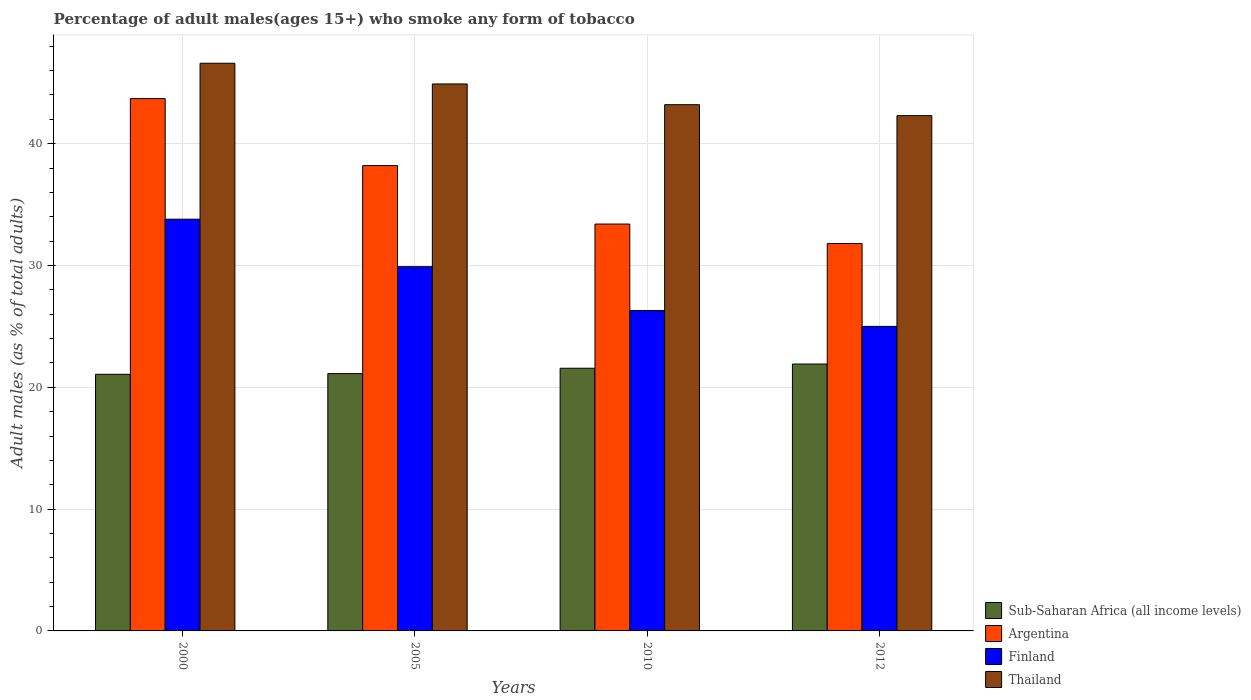How many different coloured bars are there?
Ensure brevity in your answer.  4. Are the number of bars per tick equal to the number of legend labels?
Your answer should be very brief. Yes. Are the number of bars on each tick of the X-axis equal?
Your response must be concise. Yes. How many bars are there on the 1st tick from the left?
Provide a short and direct response. 4. How many bars are there on the 4th tick from the right?
Provide a succinct answer. 4. What is the label of the 4th group of bars from the left?
Ensure brevity in your answer.  2012. In how many cases, is the number of bars for a given year not equal to the number of legend labels?
Provide a succinct answer. 0. What is the percentage of adult males who smoke in Finland in 2000?
Ensure brevity in your answer.  33.8. Across all years, what is the maximum percentage of adult males who smoke in Finland?
Offer a very short reply. 33.8. Across all years, what is the minimum percentage of adult males who smoke in Thailand?
Provide a short and direct response. 42.3. In which year was the percentage of adult males who smoke in Thailand maximum?
Your response must be concise. 2000. What is the total percentage of adult males who smoke in Sub-Saharan Africa (all income levels) in the graph?
Offer a very short reply. 85.66. What is the difference between the percentage of adult males who smoke in Thailand in 2000 and that in 2005?
Provide a short and direct response. 1.7. What is the difference between the percentage of adult males who smoke in Thailand in 2005 and the percentage of adult males who smoke in Sub-Saharan Africa (all income levels) in 2012?
Offer a very short reply. 22.99. What is the average percentage of adult males who smoke in Finland per year?
Give a very brief answer. 28.75. In the year 2012, what is the difference between the percentage of adult males who smoke in Finland and percentage of adult males who smoke in Thailand?
Your response must be concise. -17.3. In how many years, is the percentage of adult males who smoke in Thailand greater than 8 %?
Offer a very short reply. 4. What is the ratio of the percentage of adult males who smoke in Finland in 2000 to that in 2005?
Keep it short and to the point. 1.13. Is the percentage of adult males who smoke in Argentina in 2010 less than that in 2012?
Provide a short and direct response. No. What is the difference between the highest and the second highest percentage of adult males who smoke in Sub-Saharan Africa (all income levels)?
Your answer should be very brief. 0.35. What is the difference between the highest and the lowest percentage of adult males who smoke in Thailand?
Provide a short and direct response. 4.3. What does the 1st bar from the right in 2010 represents?
Offer a terse response. Thailand. How many bars are there?
Ensure brevity in your answer.  16. Are all the bars in the graph horizontal?
Offer a terse response. No. What is the difference between two consecutive major ticks on the Y-axis?
Provide a succinct answer. 10. How are the legend labels stacked?
Your response must be concise. Vertical. What is the title of the graph?
Provide a short and direct response. Percentage of adult males(ages 15+) who smoke any form of tobacco. Does "Heavily indebted poor countries" appear as one of the legend labels in the graph?
Provide a succinct answer. No. What is the label or title of the Y-axis?
Keep it short and to the point. Adult males (as % of total adults). What is the Adult males (as % of total adults) of Sub-Saharan Africa (all income levels) in 2000?
Keep it short and to the point. 21.07. What is the Adult males (as % of total adults) of Argentina in 2000?
Your answer should be compact. 43.7. What is the Adult males (as % of total adults) in Finland in 2000?
Ensure brevity in your answer.  33.8. What is the Adult males (as % of total adults) of Thailand in 2000?
Your answer should be very brief. 46.6. What is the Adult males (as % of total adults) in Sub-Saharan Africa (all income levels) in 2005?
Give a very brief answer. 21.12. What is the Adult males (as % of total adults) of Argentina in 2005?
Give a very brief answer. 38.2. What is the Adult males (as % of total adults) in Finland in 2005?
Give a very brief answer. 29.9. What is the Adult males (as % of total adults) in Thailand in 2005?
Offer a very short reply. 44.9. What is the Adult males (as % of total adults) in Sub-Saharan Africa (all income levels) in 2010?
Your answer should be very brief. 21.56. What is the Adult males (as % of total adults) of Argentina in 2010?
Offer a very short reply. 33.4. What is the Adult males (as % of total adults) in Finland in 2010?
Provide a succinct answer. 26.3. What is the Adult males (as % of total adults) in Thailand in 2010?
Provide a succinct answer. 43.2. What is the Adult males (as % of total adults) of Sub-Saharan Africa (all income levels) in 2012?
Keep it short and to the point. 21.91. What is the Adult males (as % of total adults) of Argentina in 2012?
Make the answer very short. 31.8. What is the Adult males (as % of total adults) of Thailand in 2012?
Ensure brevity in your answer.  42.3. Across all years, what is the maximum Adult males (as % of total adults) in Sub-Saharan Africa (all income levels)?
Provide a short and direct response. 21.91. Across all years, what is the maximum Adult males (as % of total adults) of Argentina?
Ensure brevity in your answer.  43.7. Across all years, what is the maximum Adult males (as % of total adults) of Finland?
Your answer should be compact. 33.8. Across all years, what is the maximum Adult males (as % of total adults) in Thailand?
Offer a very short reply. 46.6. Across all years, what is the minimum Adult males (as % of total adults) in Sub-Saharan Africa (all income levels)?
Offer a very short reply. 21.07. Across all years, what is the minimum Adult males (as % of total adults) of Argentina?
Keep it short and to the point. 31.8. Across all years, what is the minimum Adult males (as % of total adults) of Finland?
Offer a very short reply. 25. Across all years, what is the minimum Adult males (as % of total adults) in Thailand?
Keep it short and to the point. 42.3. What is the total Adult males (as % of total adults) of Sub-Saharan Africa (all income levels) in the graph?
Provide a short and direct response. 85.66. What is the total Adult males (as % of total adults) of Argentina in the graph?
Your response must be concise. 147.1. What is the total Adult males (as % of total adults) in Finland in the graph?
Give a very brief answer. 115. What is the total Adult males (as % of total adults) in Thailand in the graph?
Your response must be concise. 177. What is the difference between the Adult males (as % of total adults) in Sub-Saharan Africa (all income levels) in 2000 and that in 2005?
Make the answer very short. -0.06. What is the difference between the Adult males (as % of total adults) in Finland in 2000 and that in 2005?
Offer a terse response. 3.9. What is the difference between the Adult males (as % of total adults) of Sub-Saharan Africa (all income levels) in 2000 and that in 2010?
Give a very brief answer. -0.5. What is the difference between the Adult males (as % of total adults) in Finland in 2000 and that in 2010?
Offer a very short reply. 7.5. What is the difference between the Adult males (as % of total adults) of Thailand in 2000 and that in 2010?
Provide a short and direct response. 3.4. What is the difference between the Adult males (as % of total adults) of Sub-Saharan Africa (all income levels) in 2000 and that in 2012?
Give a very brief answer. -0.84. What is the difference between the Adult males (as % of total adults) in Sub-Saharan Africa (all income levels) in 2005 and that in 2010?
Offer a terse response. -0.44. What is the difference between the Adult males (as % of total adults) in Finland in 2005 and that in 2010?
Your answer should be compact. 3.6. What is the difference between the Adult males (as % of total adults) in Sub-Saharan Africa (all income levels) in 2005 and that in 2012?
Give a very brief answer. -0.79. What is the difference between the Adult males (as % of total adults) in Argentina in 2005 and that in 2012?
Ensure brevity in your answer.  6.4. What is the difference between the Adult males (as % of total adults) of Finland in 2005 and that in 2012?
Provide a short and direct response. 4.9. What is the difference between the Adult males (as % of total adults) in Thailand in 2005 and that in 2012?
Give a very brief answer. 2.6. What is the difference between the Adult males (as % of total adults) of Sub-Saharan Africa (all income levels) in 2010 and that in 2012?
Ensure brevity in your answer.  -0.35. What is the difference between the Adult males (as % of total adults) in Finland in 2010 and that in 2012?
Offer a terse response. 1.3. What is the difference between the Adult males (as % of total adults) of Thailand in 2010 and that in 2012?
Give a very brief answer. 0.9. What is the difference between the Adult males (as % of total adults) of Sub-Saharan Africa (all income levels) in 2000 and the Adult males (as % of total adults) of Argentina in 2005?
Provide a short and direct response. -17.13. What is the difference between the Adult males (as % of total adults) of Sub-Saharan Africa (all income levels) in 2000 and the Adult males (as % of total adults) of Finland in 2005?
Give a very brief answer. -8.83. What is the difference between the Adult males (as % of total adults) in Sub-Saharan Africa (all income levels) in 2000 and the Adult males (as % of total adults) in Thailand in 2005?
Offer a very short reply. -23.83. What is the difference between the Adult males (as % of total adults) in Argentina in 2000 and the Adult males (as % of total adults) in Finland in 2005?
Provide a short and direct response. 13.8. What is the difference between the Adult males (as % of total adults) of Argentina in 2000 and the Adult males (as % of total adults) of Thailand in 2005?
Ensure brevity in your answer.  -1.2. What is the difference between the Adult males (as % of total adults) of Sub-Saharan Africa (all income levels) in 2000 and the Adult males (as % of total adults) of Argentina in 2010?
Give a very brief answer. -12.33. What is the difference between the Adult males (as % of total adults) in Sub-Saharan Africa (all income levels) in 2000 and the Adult males (as % of total adults) in Finland in 2010?
Provide a succinct answer. -5.23. What is the difference between the Adult males (as % of total adults) in Sub-Saharan Africa (all income levels) in 2000 and the Adult males (as % of total adults) in Thailand in 2010?
Your answer should be very brief. -22.13. What is the difference between the Adult males (as % of total adults) in Argentina in 2000 and the Adult males (as % of total adults) in Finland in 2010?
Keep it short and to the point. 17.4. What is the difference between the Adult males (as % of total adults) in Argentina in 2000 and the Adult males (as % of total adults) in Thailand in 2010?
Your answer should be very brief. 0.5. What is the difference between the Adult males (as % of total adults) of Sub-Saharan Africa (all income levels) in 2000 and the Adult males (as % of total adults) of Argentina in 2012?
Make the answer very short. -10.73. What is the difference between the Adult males (as % of total adults) in Sub-Saharan Africa (all income levels) in 2000 and the Adult males (as % of total adults) in Finland in 2012?
Offer a very short reply. -3.93. What is the difference between the Adult males (as % of total adults) in Sub-Saharan Africa (all income levels) in 2000 and the Adult males (as % of total adults) in Thailand in 2012?
Provide a short and direct response. -21.23. What is the difference between the Adult males (as % of total adults) in Finland in 2000 and the Adult males (as % of total adults) in Thailand in 2012?
Provide a succinct answer. -8.5. What is the difference between the Adult males (as % of total adults) in Sub-Saharan Africa (all income levels) in 2005 and the Adult males (as % of total adults) in Argentina in 2010?
Give a very brief answer. -12.28. What is the difference between the Adult males (as % of total adults) in Sub-Saharan Africa (all income levels) in 2005 and the Adult males (as % of total adults) in Finland in 2010?
Your answer should be very brief. -5.18. What is the difference between the Adult males (as % of total adults) in Sub-Saharan Africa (all income levels) in 2005 and the Adult males (as % of total adults) in Thailand in 2010?
Your response must be concise. -22.08. What is the difference between the Adult males (as % of total adults) in Argentina in 2005 and the Adult males (as % of total adults) in Finland in 2010?
Ensure brevity in your answer.  11.9. What is the difference between the Adult males (as % of total adults) in Finland in 2005 and the Adult males (as % of total adults) in Thailand in 2010?
Give a very brief answer. -13.3. What is the difference between the Adult males (as % of total adults) of Sub-Saharan Africa (all income levels) in 2005 and the Adult males (as % of total adults) of Argentina in 2012?
Your answer should be compact. -10.68. What is the difference between the Adult males (as % of total adults) of Sub-Saharan Africa (all income levels) in 2005 and the Adult males (as % of total adults) of Finland in 2012?
Give a very brief answer. -3.88. What is the difference between the Adult males (as % of total adults) in Sub-Saharan Africa (all income levels) in 2005 and the Adult males (as % of total adults) in Thailand in 2012?
Your answer should be very brief. -21.18. What is the difference between the Adult males (as % of total adults) in Argentina in 2005 and the Adult males (as % of total adults) in Finland in 2012?
Keep it short and to the point. 13.2. What is the difference between the Adult males (as % of total adults) in Argentina in 2005 and the Adult males (as % of total adults) in Thailand in 2012?
Make the answer very short. -4.1. What is the difference between the Adult males (as % of total adults) of Finland in 2005 and the Adult males (as % of total adults) of Thailand in 2012?
Your answer should be compact. -12.4. What is the difference between the Adult males (as % of total adults) of Sub-Saharan Africa (all income levels) in 2010 and the Adult males (as % of total adults) of Argentina in 2012?
Keep it short and to the point. -10.24. What is the difference between the Adult males (as % of total adults) of Sub-Saharan Africa (all income levels) in 2010 and the Adult males (as % of total adults) of Finland in 2012?
Provide a short and direct response. -3.44. What is the difference between the Adult males (as % of total adults) in Sub-Saharan Africa (all income levels) in 2010 and the Adult males (as % of total adults) in Thailand in 2012?
Offer a very short reply. -20.74. What is the difference between the Adult males (as % of total adults) in Argentina in 2010 and the Adult males (as % of total adults) in Finland in 2012?
Offer a terse response. 8.4. What is the difference between the Adult males (as % of total adults) in Finland in 2010 and the Adult males (as % of total adults) in Thailand in 2012?
Give a very brief answer. -16. What is the average Adult males (as % of total adults) in Sub-Saharan Africa (all income levels) per year?
Offer a very short reply. 21.42. What is the average Adult males (as % of total adults) of Argentina per year?
Offer a terse response. 36.77. What is the average Adult males (as % of total adults) in Finland per year?
Give a very brief answer. 28.75. What is the average Adult males (as % of total adults) of Thailand per year?
Offer a terse response. 44.25. In the year 2000, what is the difference between the Adult males (as % of total adults) in Sub-Saharan Africa (all income levels) and Adult males (as % of total adults) in Argentina?
Your response must be concise. -22.63. In the year 2000, what is the difference between the Adult males (as % of total adults) of Sub-Saharan Africa (all income levels) and Adult males (as % of total adults) of Finland?
Your answer should be very brief. -12.73. In the year 2000, what is the difference between the Adult males (as % of total adults) of Sub-Saharan Africa (all income levels) and Adult males (as % of total adults) of Thailand?
Provide a succinct answer. -25.53. In the year 2000, what is the difference between the Adult males (as % of total adults) of Finland and Adult males (as % of total adults) of Thailand?
Keep it short and to the point. -12.8. In the year 2005, what is the difference between the Adult males (as % of total adults) of Sub-Saharan Africa (all income levels) and Adult males (as % of total adults) of Argentina?
Offer a terse response. -17.08. In the year 2005, what is the difference between the Adult males (as % of total adults) of Sub-Saharan Africa (all income levels) and Adult males (as % of total adults) of Finland?
Offer a very short reply. -8.78. In the year 2005, what is the difference between the Adult males (as % of total adults) of Sub-Saharan Africa (all income levels) and Adult males (as % of total adults) of Thailand?
Provide a short and direct response. -23.78. In the year 2005, what is the difference between the Adult males (as % of total adults) in Argentina and Adult males (as % of total adults) in Finland?
Offer a terse response. 8.3. In the year 2005, what is the difference between the Adult males (as % of total adults) of Argentina and Adult males (as % of total adults) of Thailand?
Your response must be concise. -6.7. In the year 2005, what is the difference between the Adult males (as % of total adults) in Finland and Adult males (as % of total adults) in Thailand?
Offer a very short reply. -15. In the year 2010, what is the difference between the Adult males (as % of total adults) of Sub-Saharan Africa (all income levels) and Adult males (as % of total adults) of Argentina?
Offer a terse response. -11.84. In the year 2010, what is the difference between the Adult males (as % of total adults) in Sub-Saharan Africa (all income levels) and Adult males (as % of total adults) in Finland?
Give a very brief answer. -4.74. In the year 2010, what is the difference between the Adult males (as % of total adults) in Sub-Saharan Africa (all income levels) and Adult males (as % of total adults) in Thailand?
Your response must be concise. -21.64. In the year 2010, what is the difference between the Adult males (as % of total adults) in Argentina and Adult males (as % of total adults) in Thailand?
Provide a succinct answer. -9.8. In the year 2010, what is the difference between the Adult males (as % of total adults) in Finland and Adult males (as % of total adults) in Thailand?
Ensure brevity in your answer.  -16.9. In the year 2012, what is the difference between the Adult males (as % of total adults) of Sub-Saharan Africa (all income levels) and Adult males (as % of total adults) of Argentina?
Provide a succinct answer. -9.89. In the year 2012, what is the difference between the Adult males (as % of total adults) of Sub-Saharan Africa (all income levels) and Adult males (as % of total adults) of Finland?
Ensure brevity in your answer.  -3.09. In the year 2012, what is the difference between the Adult males (as % of total adults) of Sub-Saharan Africa (all income levels) and Adult males (as % of total adults) of Thailand?
Offer a very short reply. -20.39. In the year 2012, what is the difference between the Adult males (as % of total adults) in Argentina and Adult males (as % of total adults) in Finland?
Your response must be concise. 6.8. In the year 2012, what is the difference between the Adult males (as % of total adults) in Argentina and Adult males (as % of total adults) in Thailand?
Keep it short and to the point. -10.5. In the year 2012, what is the difference between the Adult males (as % of total adults) in Finland and Adult males (as % of total adults) in Thailand?
Offer a terse response. -17.3. What is the ratio of the Adult males (as % of total adults) in Argentina in 2000 to that in 2005?
Keep it short and to the point. 1.14. What is the ratio of the Adult males (as % of total adults) of Finland in 2000 to that in 2005?
Provide a succinct answer. 1.13. What is the ratio of the Adult males (as % of total adults) of Thailand in 2000 to that in 2005?
Provide a succinct answer. 1.04. What is the ratio of the Adult males (as % of total adults) in Sub-Saharan Africa (all income levels) in 2000 to that in 2010?
Make the answer very short. 0.98. What is the ratio of the Adult males (as % of total adults) of Argentina in 2000 to that in 2010?
Your answer should be very brief. 1.31. What is the ratio of the Adult males (as % of total adults) in Finland in 2000 to that in 2010?
Your answer should be compact. 1.29. What is the ratio of the Adult males (as % of total adults) of Thailand in 2000 to that in 2010?
Your answer should be compact. 1.08. What is the ratio of the Adult males (as % of total adults) of Sub-Saharan Africa (all income levels) in 2000 to that in 2012?
Provide a succinct answer. 0.96. What is the ratio of the Adult males (as % of total adults) in Argentina in 2000 to that in 2012?
Your answer should be very brief. 1.37. What is the ratio of the Adult males (as % of total adults) of Finland in 2000 to that in 2012?
Offer a very short reply. 1.35. What is the ratio of the Adult males (as % of total adults) in Thailand in 2000 to that in 2012?
Offer a terse response. 1.1. What is the ratio of the Adult males (as % of total adults) of Sub-Saharan Africa (all income levels) in 2005 to that in 2010?
Provide a succinct answer. 0.98. What is the ratio of the Adult males (as % of total adults) of Argentina in 2005 to that in 2010?
Provide a short and direct response. 1.14. What is the ratio of the Adult males (as % of total adults) of Finland in 2005 to that in 2010?
Keep it short and to the point. 1.14. What is the ratio of the Adult males (as % of total adults) in Thailand in 2005 to that in 2010?
Offer a very short reply. 1.04. What is the ratio of the Adult males (as % of total adults) of Sub-Saharan Africa (all income levels) in 2005 to that in 2012?
Your answer should be very brief. 0.96. What is the ratio of the Adult males (as % of total adults) in Argentina in 2005 to that in 2012?
Offer a very short reply. 1.2. What is the ratio of the Adult males (as % of total adults) in Finland in 2005 to that in 2012?
Offer a very short reply. 1.2. What is the ratio of the Adult males (as % of total adults) of Thailand in 2005 to that in 2012?
Provide a short and direct response. 1.06. What is the ratio of the Adult males (as % of total adults) of Sub-Saharan Africa (all income levels) in 2010 to that in 2012?
Provide a succinct answer. 0.98. What is the ratio of the Adult males (as % of total adults) of Argentina in 2010 to that in 2012?
Your answer should be compact. 1.05. What is the ratio of the Adult males (as % of total adults) in Finland in 2010 to that in 2012?
Offer a very short reply. 1.05. What is the ratio of the Adult males (as % of total adults) in Thailand in 2010 to that in 2012?
Provide a succinct answer. 1.02. What is the difference between the highest and the second highest Adult males (as % of total adults) in Sub-Saharan Africa (all income levels)?
Ensure brevity in your answer.  0.35. What is the difference between the highest and the second highest Adult males (as % of total adults) of Argentina?
Your answer should be compact. 5.5. What is the difference between the highest and the lowest Adult males (as % of total adults) in Sub-Saharan Africa (all income levels)?
Give a very brief answer. 0.84. What is the difference between the highest and the lowest Adult males (as % of total adults) of Thailand?
Give a very brief answer. 4.3. 